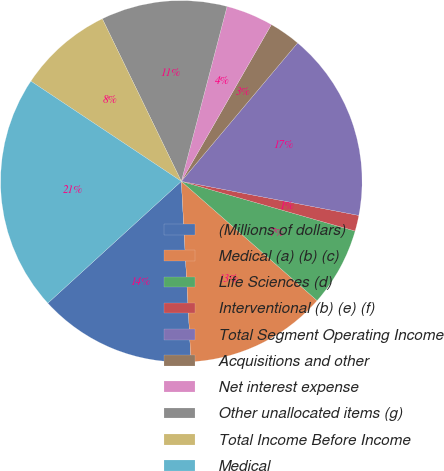Convert chart to OTSL. <chart><loc_0><loc_0><loc_500><loc_500><pie_chart><fcel>(Millions of dollars)<fcel>Medical (a) (b) (c)<fcel>Life Sciences (d)<fcel>Interventional (b) (e) (f)<fcel>Total Segment Operating Income<fcel>Acquisitions and other<fcel>Net interest expense<fcel>Other unallocated items (g)<fcel>Total Income Before Income<fcel>Medical<nl><fcel>14.08%<fcel>12.67%<fcel>7.04%<fcel>1.41%<fcel>16.9%<fcel>2.82%<fcel>4.23%<fcel>11.27%<fcel>8.45%<fcel>21.12%<nl></chart> 